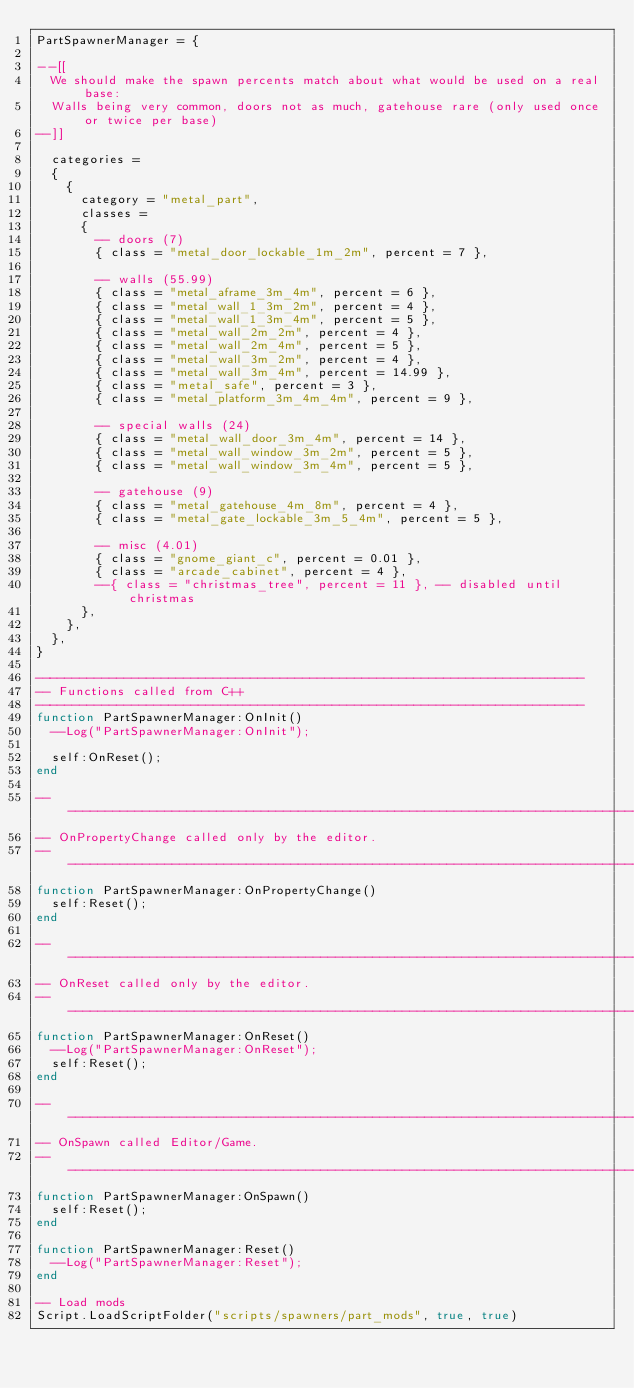<code> <loc_0><loc_0><loc_500><loc_500><_Lua_>PartSpawnerManager = {

--[[
	We should make the spawn percents match about what would be used on a real base:
	Walls being very common, doors not as much, gatehouse rare (only used once or twice per base)
--]]

	categories =
	{
		{
			category = "metal_part",
			classes =
			{
				-- doors (7)
				{ class = "metal_door_lockable_1m_2m", percent = 7 },

				-- walls (55.99)
				{ class = "metal_aframe_3m_4m", percent = 6 },
				{ class = "metal_wall_1_3m_2m", percent = 4 },
				{ class = "metal_wall_1_3m_4m", percent = 5 }, 
				{ class = "metal_wall_2m_2m", percent = 4 },
				{ class = "metal_wall_2m_4m", percent = 5 },
				{ class = "metal_wall_3m_2m", percent = 4 },
				{ class = "metal_wall_3m_4m", percent = 14.99 },
				{ class = "metal_safe", percent = 3 },
				{ class = "metal_platform_3m_4m_4m", percent = 9 },

				-- special walls (24)
				{ class = "metal_wall_door_3m_4m", percent = 14 }, 
				{ class = "metal_wall_window_3m_2m", percent = 5 },
				{ class = "metal_wall_window_3m_4m", percent = 5 },

				-- gatehouse (9)
				{ class = "metal_gatehouse_4m_8m", percent = 4 },
				{ class = "metal_gate_lockable_3m_5_4m", percent = 5 },

				-- misc (4.01)
				{ class = "gnome_giant_c", percent = 0.01 },
				{ class = "arcade_cabinet", percent = 4 },
				--{ class = "christmas_tree", percent = 11 }, -- disabled until christmas
			},
		},
	},
}

--------------------------------------------------------------------------
-- Functions called from C++
--------------------------------------------------------------------------
function PartSpawnerManager:OnInit()
	--Log("PartSpawnerManager:OnInit");

	self:OnReset();
end

------------------------------------------------------------------------------------------------------
-- OnPropertyChange called only by the editor.
------------------------------------------------------------------------------------------------------
function PartSpawnerManager:OnPropertyChange()
	self:Reset();
end

------------------------------------------------------------------------------------------------------
-- OnReset called only by the editor.
------------------------------------------------------------------------------------------------------
function PartSpawnerManager:OnReset()
	--Log("PartSpawnerManager:OnReset");
	self:Reset();
end

------------------------------------------------------------------------------------------------------
-- OnSpawn called Editor/Game.
------------------------------------------------------------------------------------------------------
function PartSpawnerManager:OnSpawn()
	self:Reset();
end

function PartSpawnerManager:Reset()
	--Log("PartSpawnerManager:Reset");
end

-- Load mods
Script.LoadScriptFolder("scripts/spawners/part_mods", true, true)</code> 